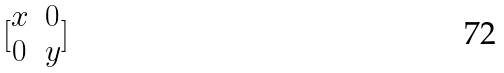<formula> <loc_0><loc_0><loc_500><loc_500>[ \begin{matrix} x & 0 \\ 0 & y \\ \end{matrix} ]</formula> 